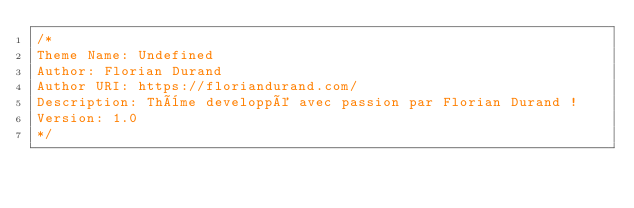<code> <loc_0><loc_0><loc_500><loc_500><_CSS_>/*
Theme Name: Undefined
Author: Florian Durand
Author URI: https://floriandurand.com/
Description: Thème developpé avec passion par Florian Durand !
Version: 1.0
*/
</code> 